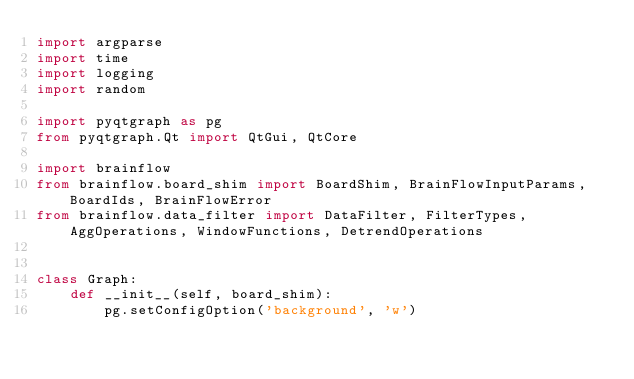Convert code to text. <code><loc_0><loc_0><loc_500><loc_500><_Python_>import argparse
import time
import logging
import random

import pyqtgraph as pg
from pyqtgraph.Qt import QtGui, QtCore

import brainflow
from brainflow.board_shim import BoardShim, BrainFlowInputParams, BoardIds, BrainFlowError
from brainflow.data_filter import DataFilter, FilterTypes, AggOperations, WindowFunctions, DetrendOperations


class Graph:
    def __init__(self, board_shim):
        pg.setConfigOption('background', 'w')</code> 